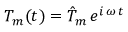Convert formula to latex. <formula><loc_0><loc_0><loc_500><loc_500>T _ { m } ( t ) = \hat { T } _ { m } \, e ^ { i \, \omega \, t }</formula> 